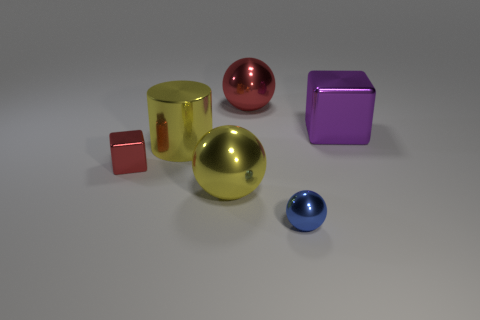Add 2 small red blocks. How many objects exist? 8 Subtract all cylinders. How many objects are left? 5 Subtract all big red matte blocks. Subtract all large yellow cylinders. How many objects are left? 5 Add 1 big shiny cubes. How many big shiny cubes are left? 2 Add 4 tiny blue matte balls. How many tiny blue matte balls exist? 4 Subtract 0 purple balls. How many objects are left? 6 